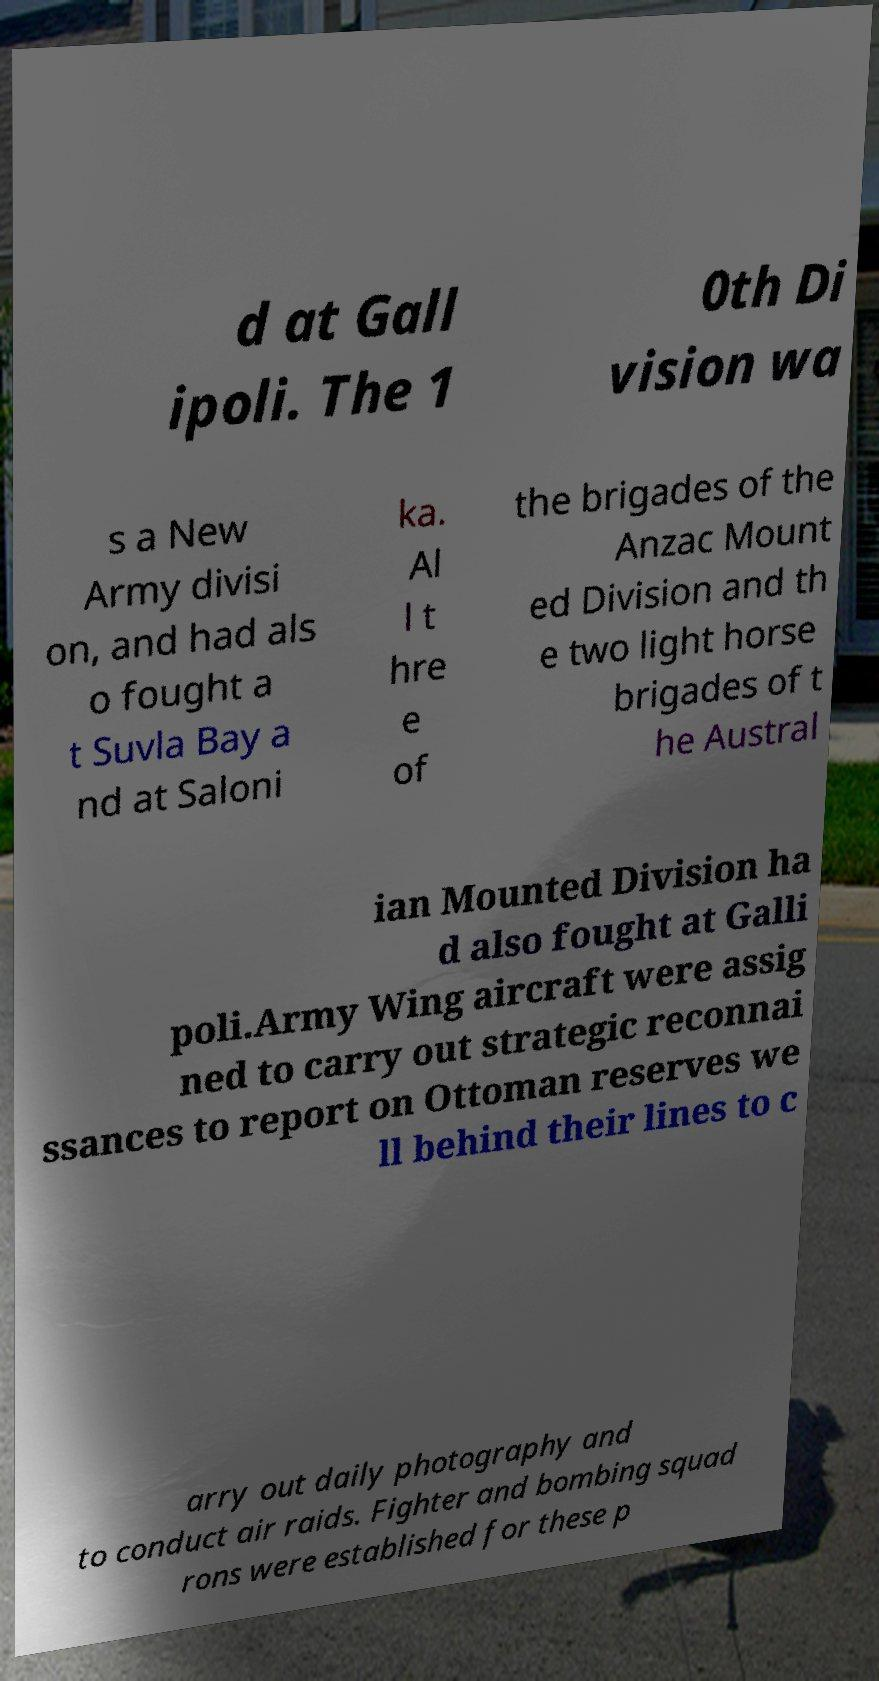I need the written content from this picture converted into text. Can you do that? d at Gall ipoli. The 1 0th Di vision wa s a New Army divisi on, and had als o fought a t Suvla Bay a nd at Saloni ka. Al l t hre e of the brigades of the Anzac Mount ed Division and th e two light horse brigades of t he Austral ian Mounted Division ha d also fought at Galli poli.Army Wing aircraft were assig ned to carry out strategic reconnai ssances to report on Ottoman reserves we ll behind their lines to c arry out daily photography and to conduct air raids. Fighter and bombing squad rons were established for these p 